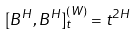Convert formula to latex. <formula><loc_0><loc_0><loc_500><loc_500>[ B ^ { H } , B ^ { H } ] ^ { ( W ) } _ { t } = t ^ { 2 H }</formula> 